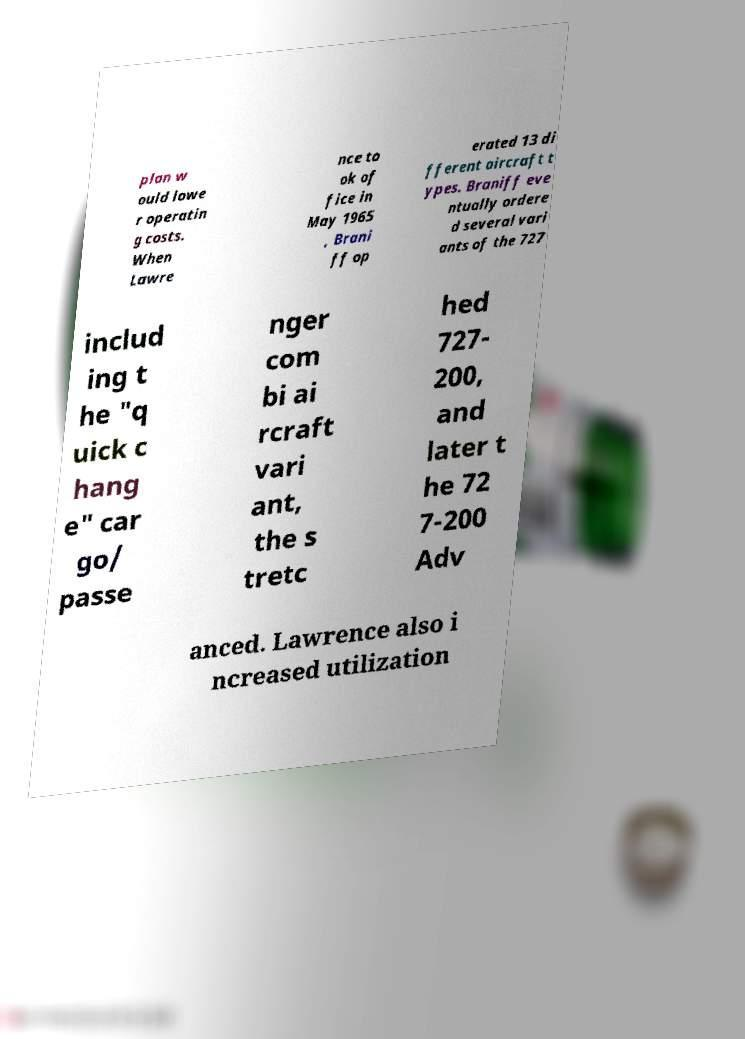Could you assist in decoding the text presented in this image and type it out clearly? plan w ould lowe r operatin g costs. When Lawre nce to ok of fice in May 1965 , Brani ff op erated 13 di fferent aircraft t ypes. Braniff eve ntually ordere d several vari ants of the 727 includ ing t he "q uick c hang e" car go/ passe nger com bi ai rcraft vari ant, the s tretc hed 727- 200, and later t he 72 7-200 Adv anced. Lawrence also i ncreased utilization 